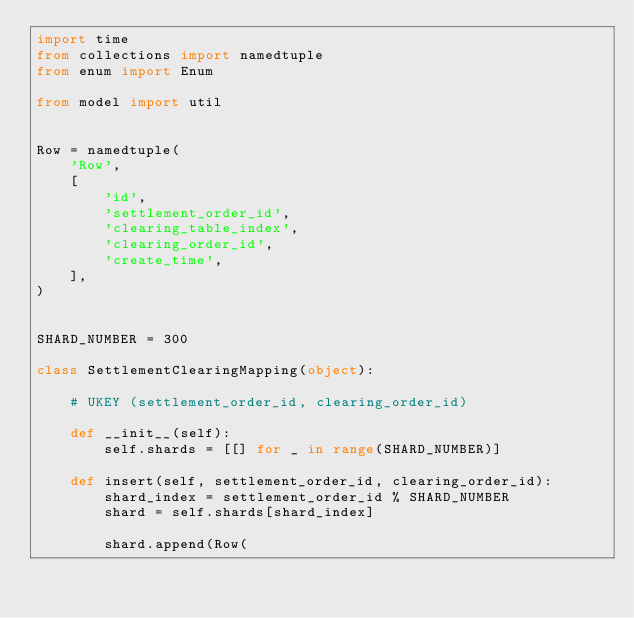Convert code to text. <code><loc_0><loc_0><loc_500><loc_500><_Python_>import time
from collections import namedtuple
from enum import Enum

from model import util


Row = namedtuple(
    'Row',
    [
        'id',
        'settlement_order_id',
        'clearing_table_index',
        'clearing_order_id',
        'create_time',
    ],
)


SHARD_NUMBER = 300

class SettlementClearingMapping(object):

    # UKEY (settlement_order_id, clearing_order_id)

    def __init__(self):
        self.shards = [[] for _ in range(SHARD_NUMBER)]

    def insert(self, settlement_order_id, clearing_order_id):
        shard_index = settlement_order_id % SHARD_NUMBER
        shard = self.shards[shard_index]

        shard.append(Row(</code> 